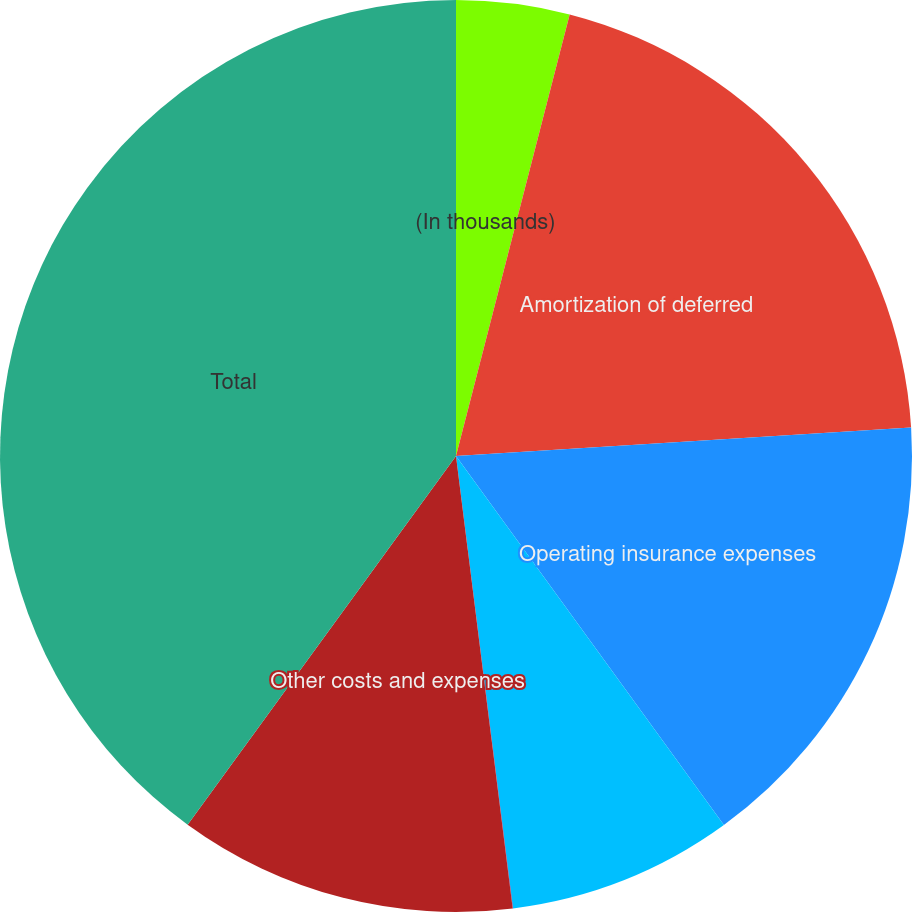<chart> <loc_0><loc_0><loc_500><loc_500><pie_chart><fcel>(In thousands)<fcel>Amortization of deferred<fcel>Operating insurance expenses<fcel>Service company expenses<fcel>Net foreign currency (gains)<fcel>Other costs and expenses<fcel>Total<nl><fcel>4.01%<fcel>20.0%<fcel>16.0%<fcel>8.0%<fcel>0.01%<fcel>12.0%<fcel>39.99%<nl></chart> 